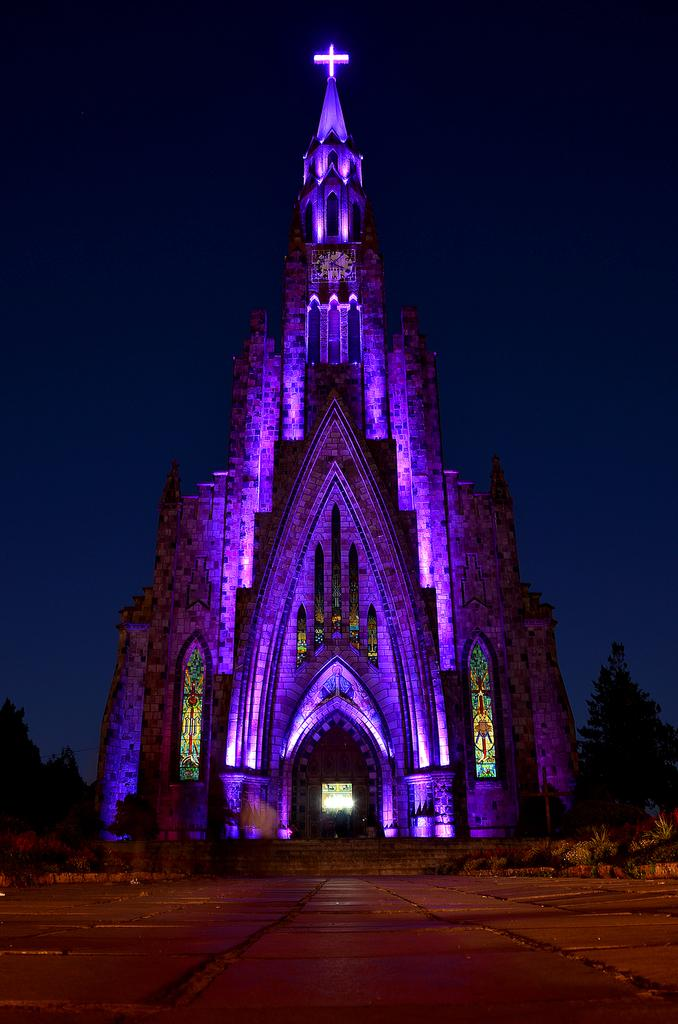What type of structure is present in the image? There is a building with windows in the image. What can be seen inside the building? Lights are visible in the image. How can one access different levels of the building? There is a staircase in the image. What type of vegetation is present in the image? There are plants and trees in the image. What is visible in the background of the image? The sky is visible in the image. What type of key is used to unlock the committee's decision-making process in the image? There is no committee or decision-making process present in the image; it features a building with lights, a staircase, plants, trees, and the sky. How does the building's acoustics affect the sound quality in the image? The image does not provide information about the building's acoustics or the sound quality inside the building. 